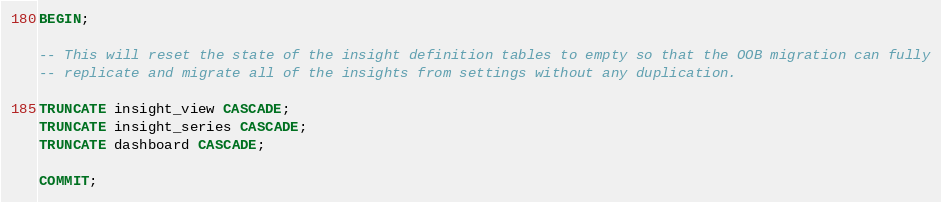Convert code to text. <code><loc_0><loc_0><loc_500><loc_500><_SQL_>BEGIN;

-- This will reset the state of the insight definition tables to empty so that the OOB migration can fully
-- replicate and migrate all of the insights from settings without any duplication.

TRUNCATE insight_view CASCADE;
TRUNCATE insight_series CASCADE;
TRUNCATE dashboard CASCADE;

COMMIT;
</code> 